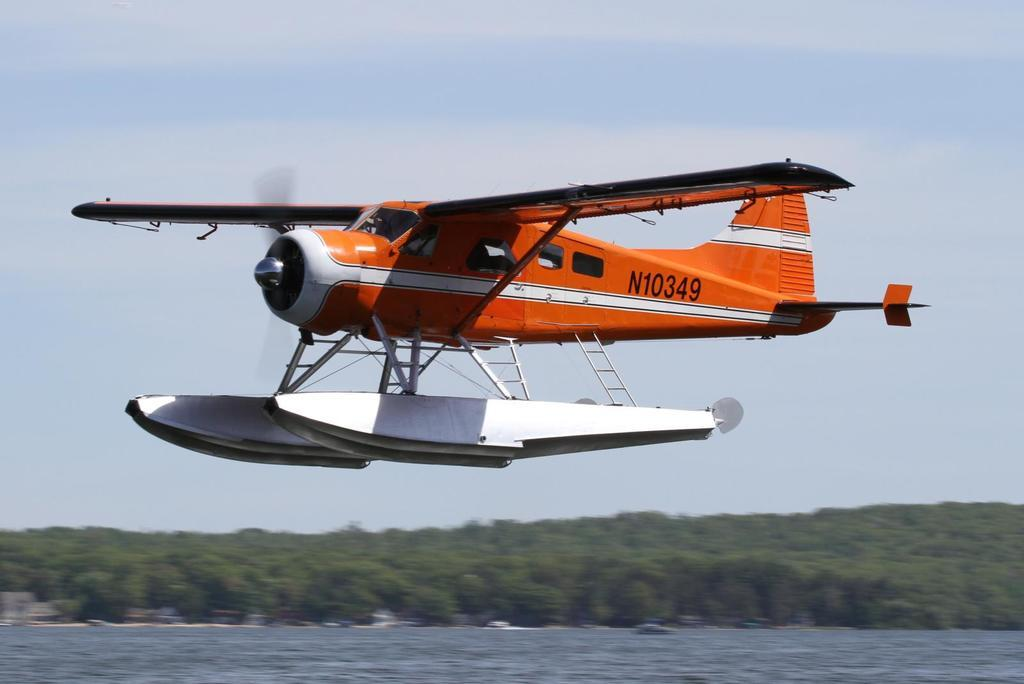Provide a one-sentence caption for the provided image. An orange sea plane bearing the ID n10349 flies over open water. 